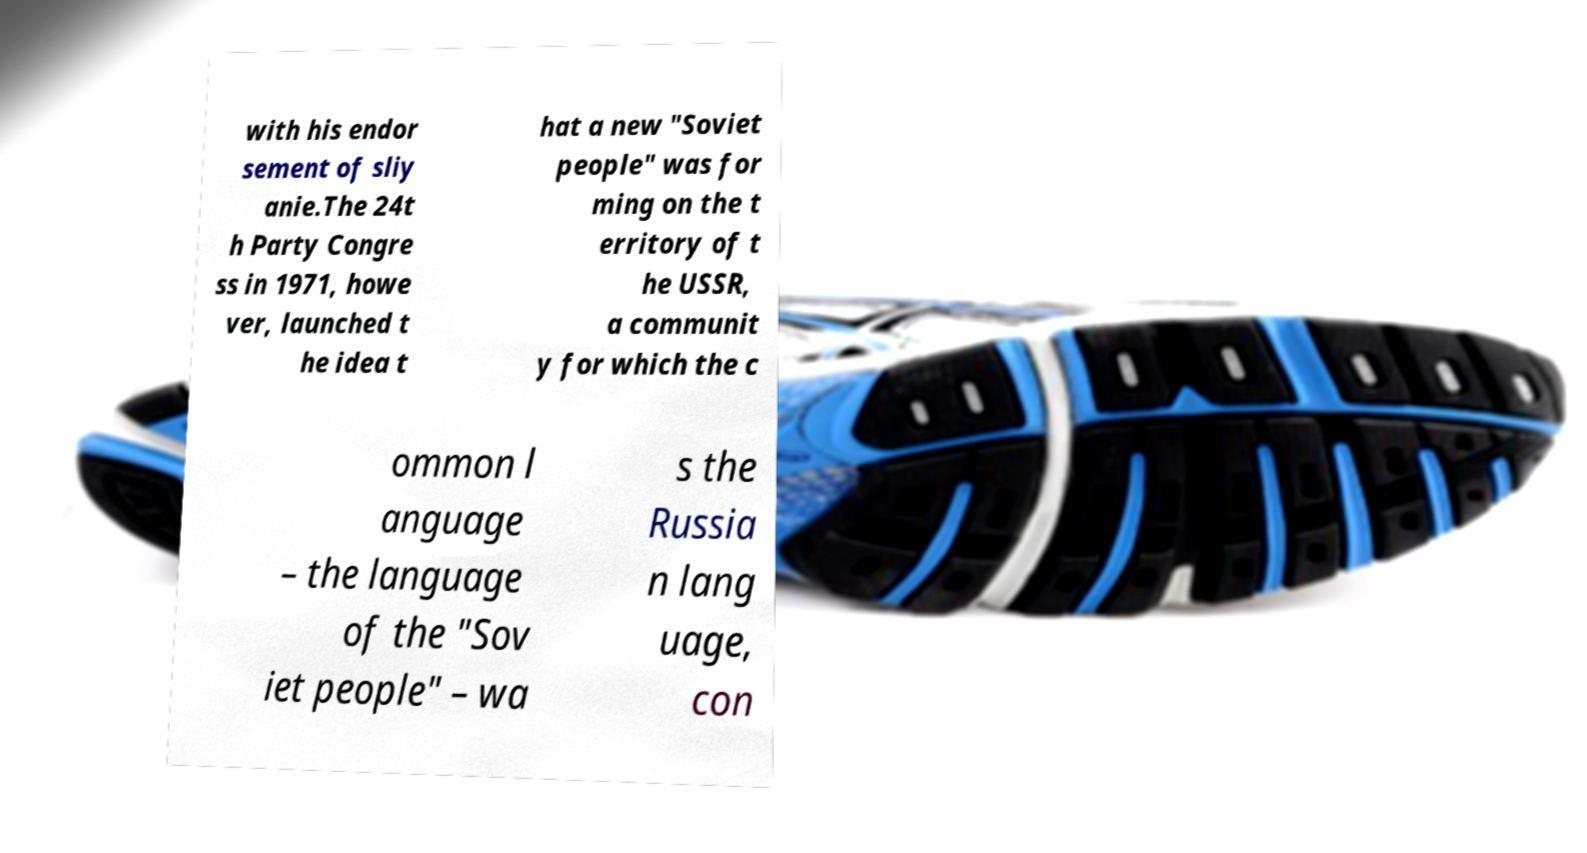Please identify and transcribe the text found in this image. with his endor sement of sliy anie.The 24t h Party Congre ss in 1971, howe ver, launched t he idea t hat a new "Soviet people" was for ming on the t erritory of t he USSR, a communit y for which the c ommon l anguage – the language of the "Sov iet people" – wa s the Russia n lang uage, con 